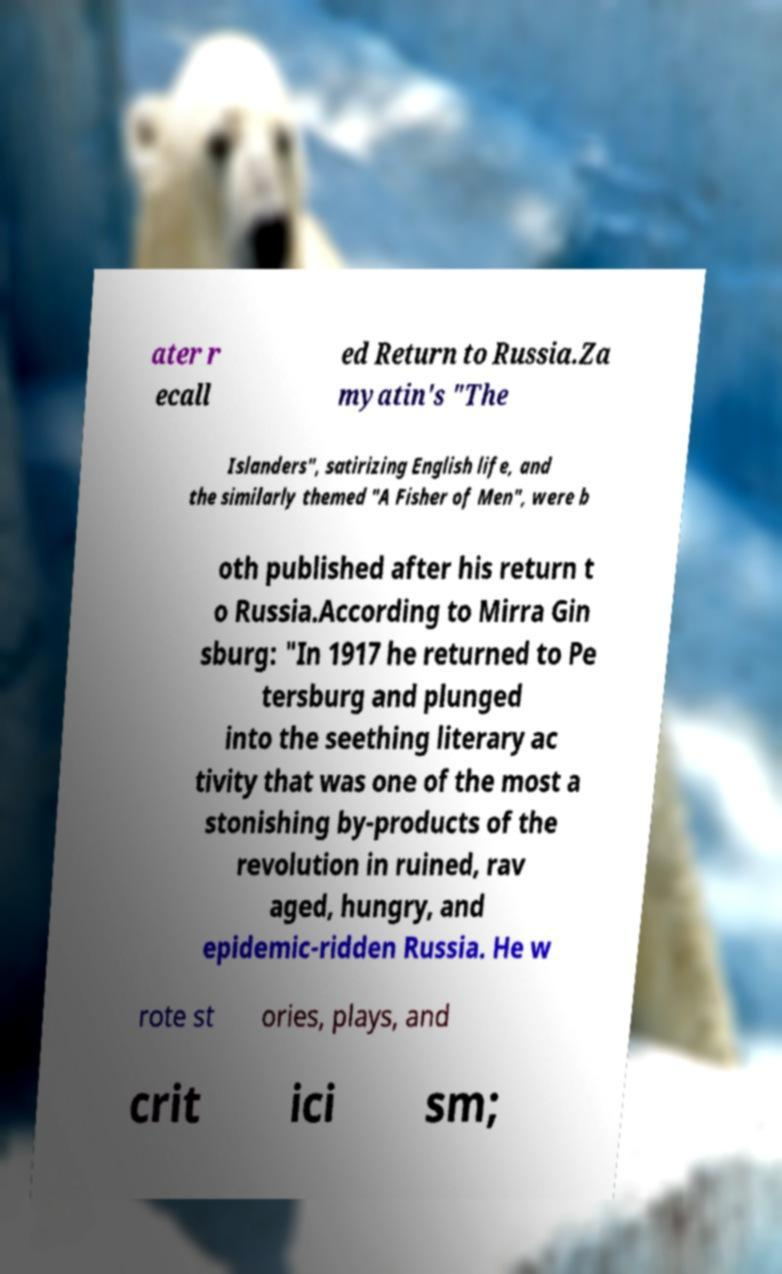Please read and relay the text visible in this image. What does it say? ater r ecall ed Return to Russia.Za myatin's "The Islanders", satirizing English life, and the similarly themed "A Fisher of Men", were b oth published after his return t o Russia.According to Mirra Gin sburg: "In 1917 he returned to Pe tersburg and plunged into the seething literary ac tivity that was one of the most a stonishing by-products of the revolution in ruined, rav aged, hungry, and epidemic-ridden Russia. He w rote st ories, plays, and crit ici sm; 